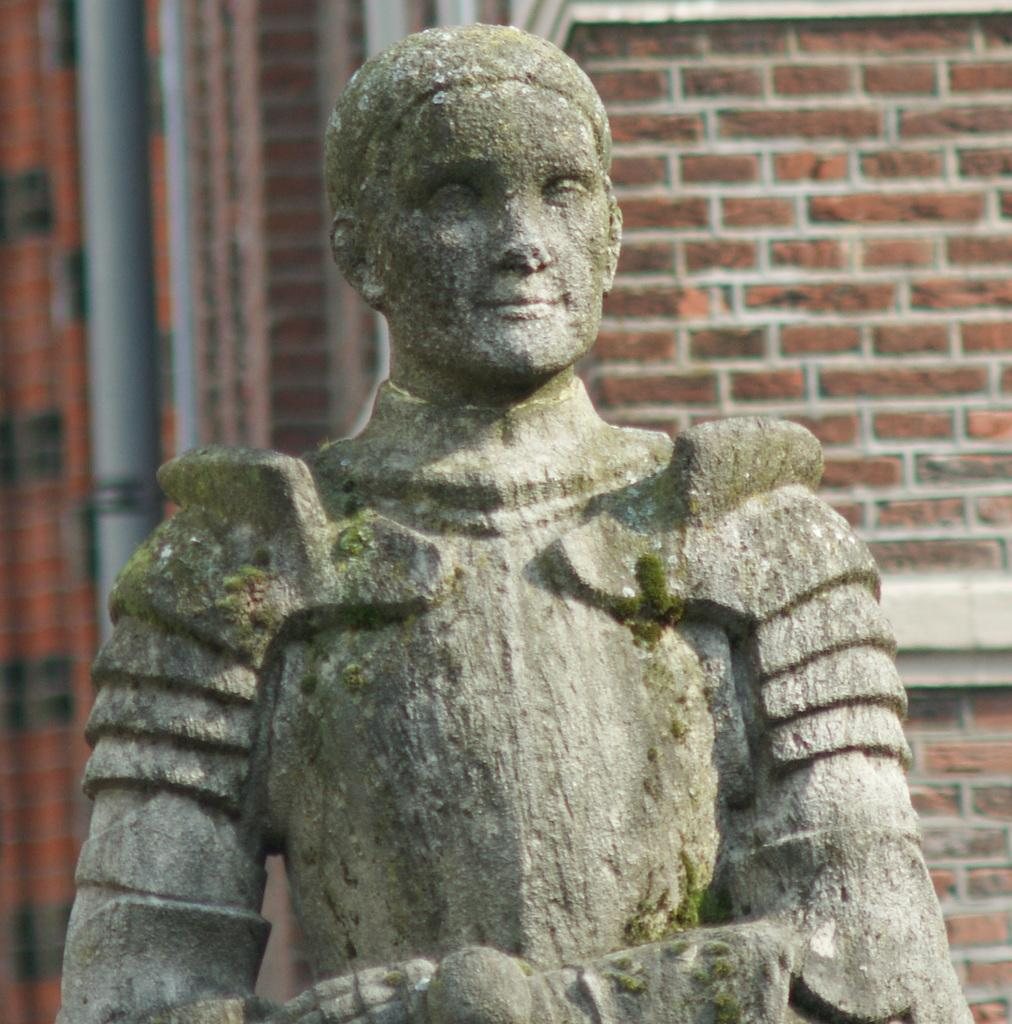What is the main subject of the image? There is a person's statue in the image. What can be seen in the background of the image? There is a brick wall of a building in the background of the image. Are there any additional features near the brick wall? Yes, there are two pipes near the brick wall in the background of the image. What type of wax is used to cover the statue in the image? There is no mention of wax or any covering on the statue in the image. 